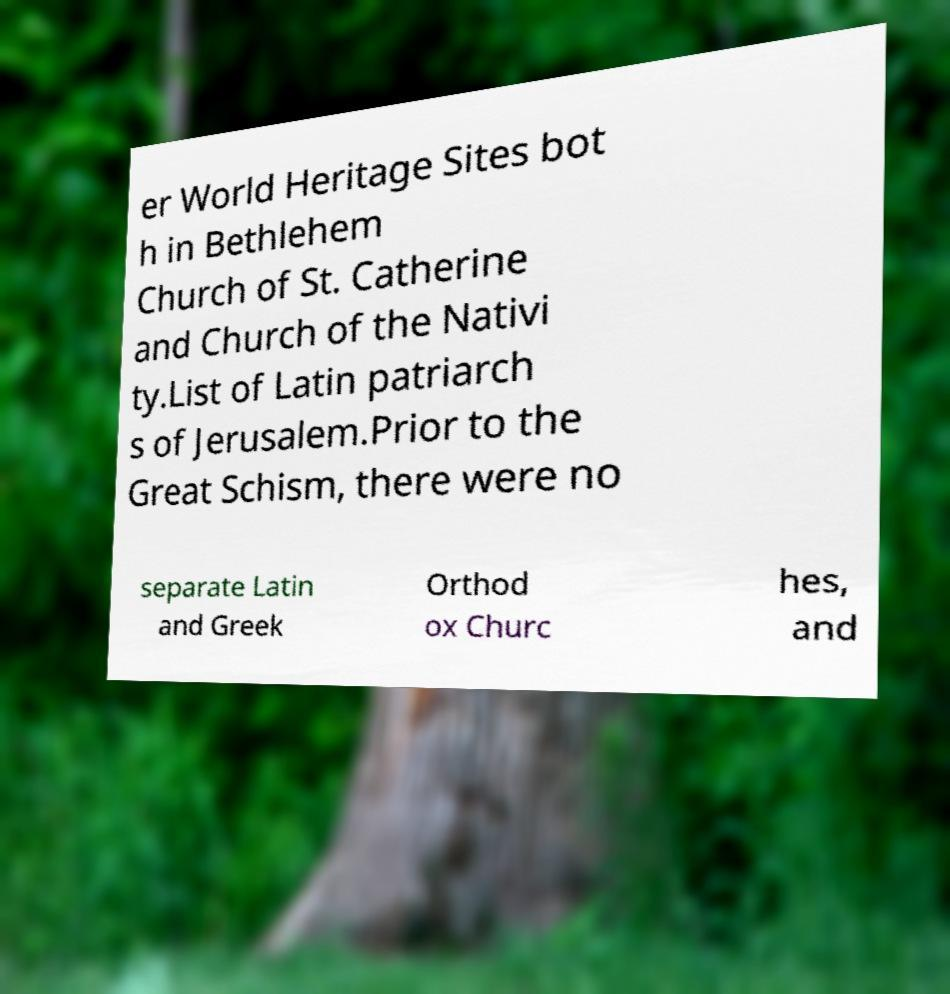Can you accurately transcribe the text from the provided image for me? er World Heritage Sites bot h in Bethlehem Church of St. Catherine and Church of the Nativi ty.List of Latin patriarch s of Jerusalem.Prior to the Great Schism, there were no separate Latin and Greek Orthod ox Churc hes, and 